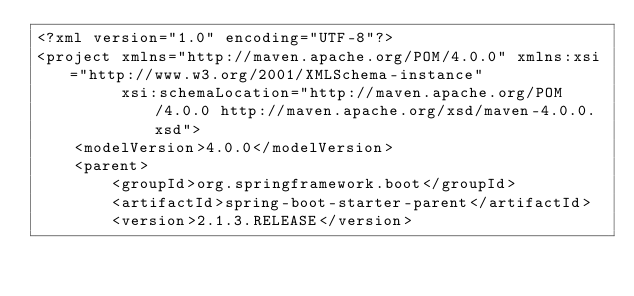Convert code to text. <code><loc_0><loc_0><loc_500><loc_500><_XML_><?xml version="1.0" encoding="UTF-8"?>
<project xmlns="http://maven.apache.org/POM/4.0.0" xmlns:xsi="http://www.w3.org/2001/XMLSchema-instance"
         xsi:schemaLocation="http://maven.apache.org/POM/4.0.0 http://maven.apache.org/xsd/maven-4.0.0.xsd">
    <modelVersion>4.0.0</modelVersion>
    <parent>
        <groupId>org.springframework.boot</groupId>
        <artifactId>spring-boot-starter-parent</artifactId>
        <version>2.1.3.RELEASE</version></code> 